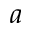Convert formula to latex. <formula><loc_0><loc_0><loc_500><loc_500>a</formula> 